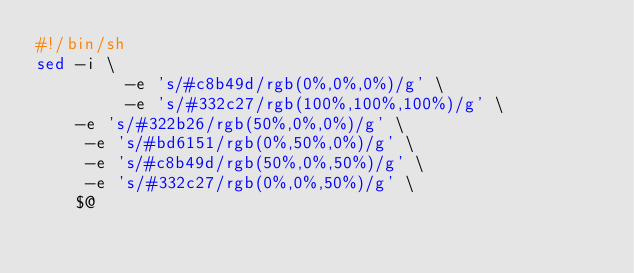<code> <loc_0><loc_0><loc_500><loc_500><_Bash_>#!/bin/sh
sed -i \
         -e 's/#c8b49d/rgb(0%,0%,0%)/g' \
         -e 's/#332c27/rgb(100%,100%,100%)/g' \
    -e 's/#322b26/rgb(50%,0%,0%)/g' \
     -e 's/#bd6151/rgb(0%,50%,0%)/g' \
     -e 's/#c8b49d/rgb(50%,0%,50%)/g' \
     -e 's/#332c27/rgb(0%,0%,50%)/g' \
	$@
</code> 